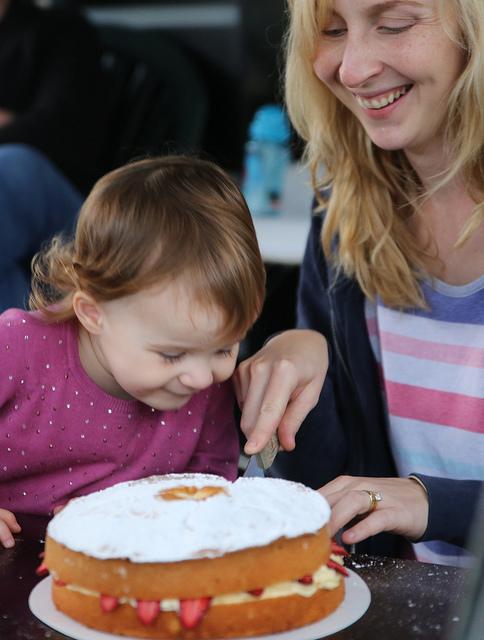Where is a baby bottle?
Give a very brief answer. Behind. Is this baby excited?
Give a very brief answer. Yes. What type of fruit is in the cake?
Short answer required. Strawberry. 